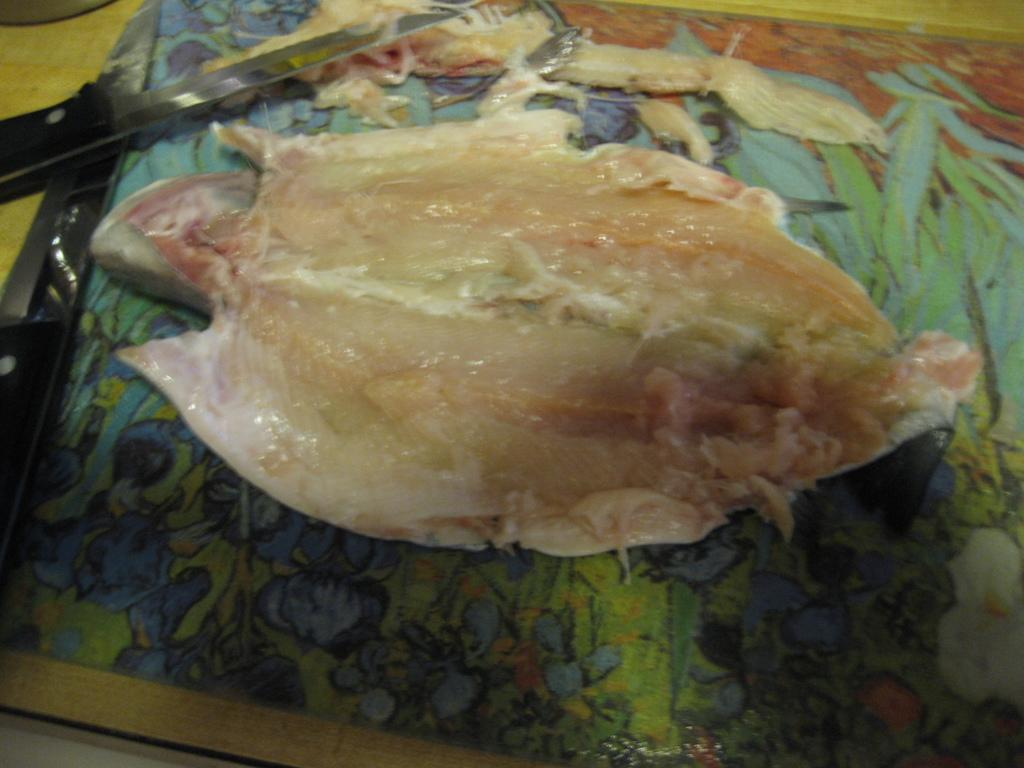What is the main subject in the foreground of the image? There is a fish in the foreground of the image. What object can be seen on a table in the image? There is a knife on a table in the image. Can you describe the possible location where the image was taken? The image may have been taken in a house. How many zebras are present in the image? There are no zebras present in the image. What type of government is depicted in the image? There is no depiction of a government in the image. 